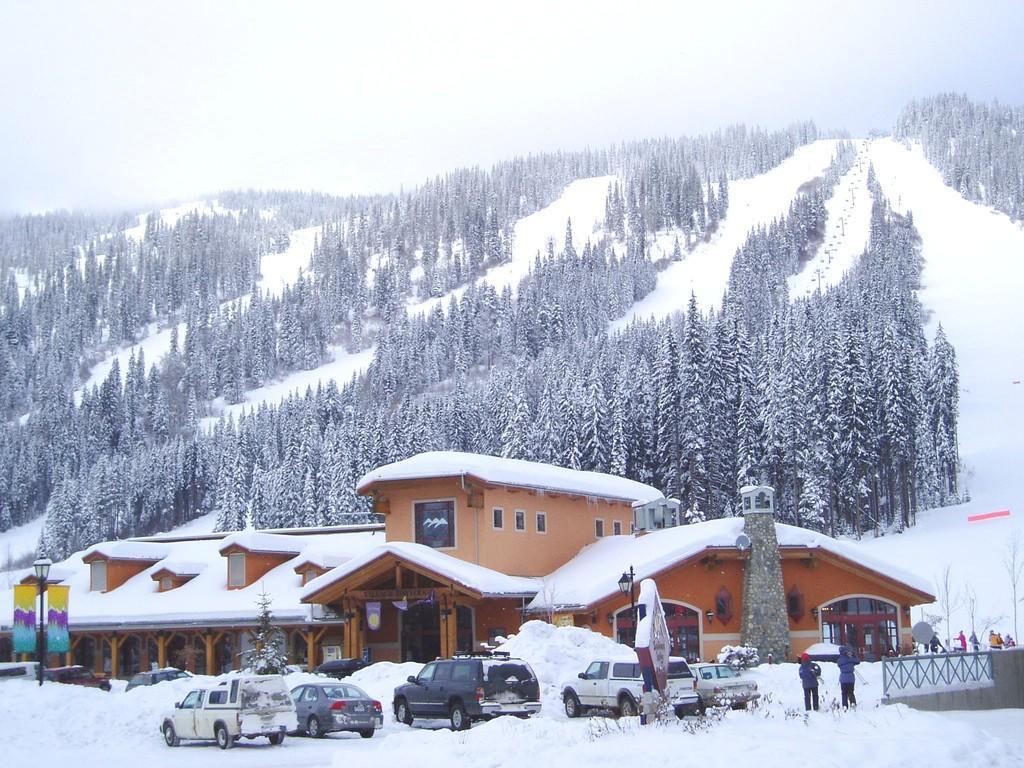Describe this image in one or two sentences. In this picture there are few vehicles on the snow and there is a building and trees covered with snow in the background. 